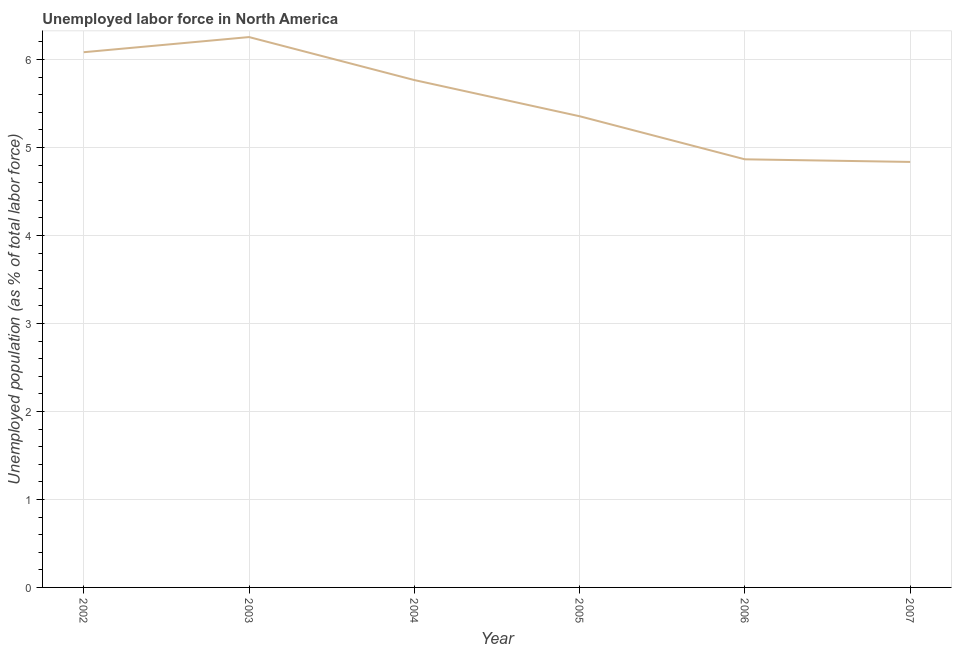What is the total unemployed population in 2004?
Offer a terse response. 5.77. Across all years, what is the maximum total unemployed population?
Keep it short and to the point. 6.26. Across all years, what is the minimum total unemployed population?
Provide a short and direct response. 4.84. What is the sum of the total unemployed population?
Offer a terse response. 33.16. What is the difference between the total unemployed population in 2005 and 2006?
Offer a terse response. 0.49. What is the average total unemployed population per year?
Provide a succinct answer. 5.53. What is the median total unemployed population?
Your answer should be compact. 5.56. Do a majority of the years between 2005 and 2007 (inclusive) have total unemployed population greater than 0.2 %?
Your answer should be compact. Yes. What is the ratio of the total unemployed population in 2002 to that in 2006?
Provide a short and direct response. 1.25. Is the difference between the total unemployed population in 2005 and 2006 greater than the difference between any two years?
Offer a very short reply. No. What is the difference between the highest and the second highest total unemployed population?
Your response must be concise. 0.17. Is the sum of the total unemployed population in 2003 and 2006 greater than the maximum total unemployed population across all years?
Your answer should be compact. Yes. What is the difference between the highest and the lowest total unemployed population?
Your answer should be very brief. 1.42. Does the total unemployed population monotonically increase over the years?
Your response must be concise. No. How many years are there in the graph?
Give a very brief answer. 6. What is the difference between two consecutive major ticks on the Y-axis?
Provide a short and direct response. 1. Does the graph contain any zero values?
Keep it short and to the point. No. What is the title of the graph?
Make the answer very short. Unemployed labor force in North America. What is the label or title of the X-axis?
Your answer should be compact. Year. What is the label or title of the Y-axis?
Your answer should be compact. Unemployed population (as % of total labor force). What is the Unemployed population (as % of total labor force) in 2002?
Offer a very short reply. 6.08. What is the Unemployed population (as % of total labor force) of 2003?
Ensure brevity in your answer.  6.26. What is the Unemployed population (as % of total labor force) in 2004?
Your answer should be very brief. 5.77. What is the Unemployed population (as % of total labor force) of 2005?
Provide a short and direct response. 5.36. What is the Unemployed population (as % of total labor force) in 2006?
Ensure brevity in your answer.  4.87. What is the Unemployed population (as % of total labor force) in 2007?
Give a very brief answer. 4.84. What is the difference between the Unemployed population (as % of total labor force) in 2002 and 2003?
Provide a short and direct response. -0.17. What is the difference between the Unemployed population (as % of total labor force) in 2002 and 2004?
Provide a short and direct response. 0.32. What is the difference between the Unemployed population (as % of total labor force) in 2002 and 2005?
Ensure brevity in your answer.  0.73. What is the difference between the Unemployed population (as % of total labor force) in 2002 and 2006?
Your answer should be very brief. 1.22. What is the difference between the Unemployed population (as % of total labor force) in 2002 and 2007?
Make the answer very short. 1.25. What is the difference between the Unemployed population (as % of total labor force) in 2003 and 2004?
Your response must be concise. 0.49. What is the difference between the Unemployed population (as % of total labor force) in 2003 and 2005?
Your answer should be very brief. 0.9. What is the difference between the Unemployed population (as % of total labor force) in 2003 and 2006?
Your response must be concise. 1.39. What is the difference between the Unemployed population (as % of total labor force) in 2003 and 2007?
Your answer should be very brief. 1.42. What is the difference between the Unemployed population (as % of total labor force) in 2004 and 2005?
Offer a terse response. 0.41. What is the difference between the Unemployed population (as % of total labor force) in 2004 and 2006?
Your answer should be very brief. 0.9. What is the difference between the Unemployed population (as % of total labor force) in 2004 and 2007?
Keep it short and to the point. 0.93. What is the difference between the Unemployed population (as % of total labor force) in 2005 and 2006?
Give a very brief answer. 0.49. What is the difference between the Unemployed population (as % of total labor force) in 2005 and 2007?
Provide a short and direct response. 0.52. What is the difference between the Unemployed population (as % of total labor force) in 2006 and 2007?
Your response must be concise. 0.03. What is the ratio of the Unemployed population (as % of total labor force) in 2002 to that in 2003?
Your response must be concise. 0.97. What is the ratio of the Unemployed population (as % of total labor force) in 2002 to that in 2004?
Ensure brevity in your answer.  1.05. What is the ratio of the Unemployed population (as % of total labor force) in 2002 to that in 2005?
Provide a short and direct response. 1.14. What is the ratio of the Unemployed population (as % of total labor force) in 2002 to that in 2006?
Give a very brief answer. 1.25. What is the ratio of the Unemployed population (as % of total labor force) in 2002 to that in 2007?
Make the answer very short. 1.26. What is the ratio of the Unemployed population (as % of total labor force) in 2003 to that in 2004?
Provide a short and direct response. 1.08. What is the ratio of the Unemployed population (as % of total labor force) in 2003 to that in 2005?
Provide a succinct answer. 1.17. What is the ratio of the Unemployed population (as % of total labor force) in 2003 to that in 2006?
Your response must be concise. 1.29. What is the ratio of the Unemployed population (as % of total labor force) in 2003 to that in 2007?
Provide a short and direct response. 1.29. What is the ratio of the Unemployed population (as % of total labor force) in 2004 to that in 2005?
Your answer should be compact. 1.08. What is the ratio of the Unemployed population (as % of total labor force) in 2004 to that in 2006?
Provide a succinct answer. 1.19. What is the ratio of the Unemployed population (as % of total labor force) in 2004 to that in 2007?
Give a very brief answer. 1.19. What is the ratio of the Unemployed population (as % of total labor force) in 2005 to that in 2006?
Provide a succinct answer. 1.1. What is the ratio of the Unemployed population (as % of total labor force) in 2005 to that in 2007?
Your answer should be very brief. 1.11. What is the ratio of the Unemployed population (as % of total labor force) in 2006 to that in 2007?
Provide a short and direct response. 1.01. 